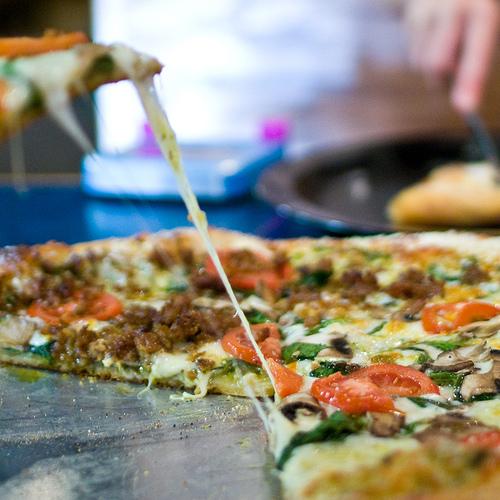How many slices have been picked?
Answer briefly. 2. What is the red item on the pizza?
Quick response, please. Tomato. What type of pizza is this?
Give a very brief answer. Supreme. Is it cheesy?
Concise answer only. Yes. 